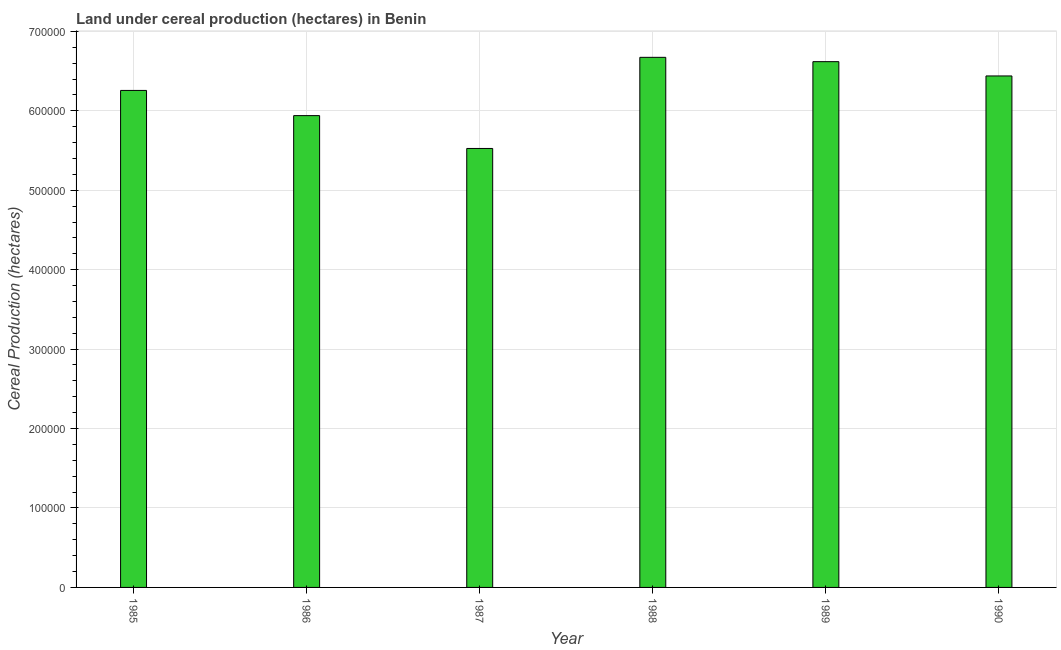Does the graph contain grids?
Make the answer very short. Yes. What is the title of the graph?
Give a very brief answer. Land under cereal production (hectares) in Benin. What is the label or title of the X-axis?
Provide a short and direct response. Year. What is the label or title of the Y-axis?
Make the answer very short. Cereal Production (hectares). What is the land under cereal production in 1990?
Provide a short and direct response. 6.44e+05. Across all years, what is the maximum land under cereal production?
Provide a succinct answer. 6.67e+05. Across all years, what is the minimum land under cereal production?
Your answer should be compact. 5.53e+05. What is the sum of the land under cereal production?
Provide a short and direct response. 3.75e+06. What is the difference between the land under cereal production in 1986 and 1990?
Provide a short and direct response. -4.99e+04. What is the average land under cereal production per year?
Offer a terse response. 6.24e+05. What is the median land under cereal production?
Ensure brevity in your answer.  6.35e+05. In how many years, is the land under cereal production greater than 320000 hectares?
Offer a very short reply. 6. What is the ratio of the land under cereal production in 1987 to that in 1988?
Your answer should be compact. 0.83. Is the land under cereal production in 1988 less than that in 1990?
Offer a very short reply. No. What is the difference between the highest and the second highest land under cereal production?
Keep it short and to the point. 5458. Is the sum of the land under cereal production in 1988 and 1989 greater than the maximum land under cereal production across all years?
Offer a very short reply. Yes. What is the difference between the highest and the lowest land under cereal production?
Offer a very short reply. 1.15e+05. In how many years, is the land under cereal production greater than the average land under cereal production taken over all years?
Make the answer very short. 4. How many bars are there?
Keep it short and to the point. 6. What is the difference between two consecutive major ticks on the Y-axis?
Your answer should be compact. 1.00e+05. Are the values on the major ticks of Y-axis written in scientific E-notation?
Make the answer very short. No. What is the Cereal Production (hectares) in 1985?
Offer a terse response. 6.26e+05. What is the Cereal Production (hectares) of 1986?
Keep it short and to the point. 5.94e+05. What is the Cereal Production (hectares) in 1987?
Offer a terse response. 5.53e+05. What is the Cereal Production (hectares) in 1988?
Offer a terse response. 6.67e+05. What is the Cereal Production (hectares) in 1989?
Offer a terse response. 6.62e+05. What is the Cereal Production (hectares) of 1990?
Make the answer very short. 6.44e+05. What is the difference between the Cereal Production (hectares) in 1985 and 1986?
Keep it short and to the point. 3.17e+04. What is the difference between the Cereal Production (hectares) in 1985 and 1987?
Provide a short and direct response. 7.31e+04. What is the difference between the Cereal Production (hectares) in 1985 and 1988?
Your answer should be compact. -4.17e+04. What is the difference between the Cereal Production (hectares) in 1985 and 1989?
Ensure brevity in your answer.  -3.62e+04. What is the difference between the Cereal Production (hectares) in 1985 and 1990?
Give a very brief answer. -1.82e+04. What is the difference between the Cereal Production (hectares) in 1986 and 1987?
Your response must be concise. 4.14e+04. What is the difference between the Cereal Production (hectares) in 1986 and 1988?
Keep it short and to the point. -7.34e+04. What is the difference between the Cereal Production (hectares) in 1986 and 1989?
Provide a short and direct response. -6.79e+04. What is the difference between the Cereal Production (hectares) in 1986 and 1990?
Make the answer very short. -4.99e+04. What is the difference between the Cereal Production (hectares) in 1987 and 1988?
Provide a short and direct response. -1.15e+05. What is the difference between the Cereal Production (hectares) in 1987 and 1989?
Keep it short and to the point. -1.09e+05. What is the difference between the Cereal Production (hectares) in 1987 and 1990?
Provide a succinct answer. -9.13e+04. What is the difference between the Cereal Production (hectares) in 1988 and 1989?
Provide a succinct answer. 5458. What is the difference between the Cereal Production (hectares) in 1988 and 1990?
Provide a short and direct response. 2.34e+04. What is the difference between the Cereal Production (hectares) in 1989 and 1990?
Your answer should be very brief. 1.80e+04. What is the ratio of the Cereal Production (hectares) in 1985 to that in 1986?
Make the answer very short. 1.05. What is the ratio of the Cereal Production (hectares) in 1985 to that in 1987?
Make the answer very short. 1.13. What is the ratio of the Cereal Production (hectares) in 1985 to that in 1988?
Your response must be concise. 0.94. What is the ratio of the Cereal Production (hectares) in 1985 to that in 1989?
Your answer should be compact. 0.94. What is the ratio of the Cereal Production (hectares) in 1986 to that in 1987?
Provide a short and direct response. 1.07. What is the ratio of the Cereal Production (hectares) in 1986 to that in 1988?
Ensure brevity in your answer.  0.89. What is the ratio of the Cereal Production (hectares) in 1986 to that in 1989?
Provide a short and direct response. 0.9. What is the ratio of the Cereal Production (hectares) in 1986 to that in 1990?
Provide a short and direct response. 0.92. What is the ratio of the Cereal Production (hectares) in 1987 to that in 1988?
Offer a terse response. 0.83. What is the ratio of the Cereal Production (hectares) in 1987 to that in 1989?
Give a very brief answer. 0.83. What is the ratio of the Cereal Production (hectares) in 1987 to that in 1990?
Your answer should be very brief. 0.86. What is the ratio of the Cereal Production (hectares) in 1988 to that in 1990?
Ensure brevity in your answer.  1.04. What is the ratio of the Cereal Production (hectares) in 1989 to that in 1990?
Provide a short and direct response. 1.03. 